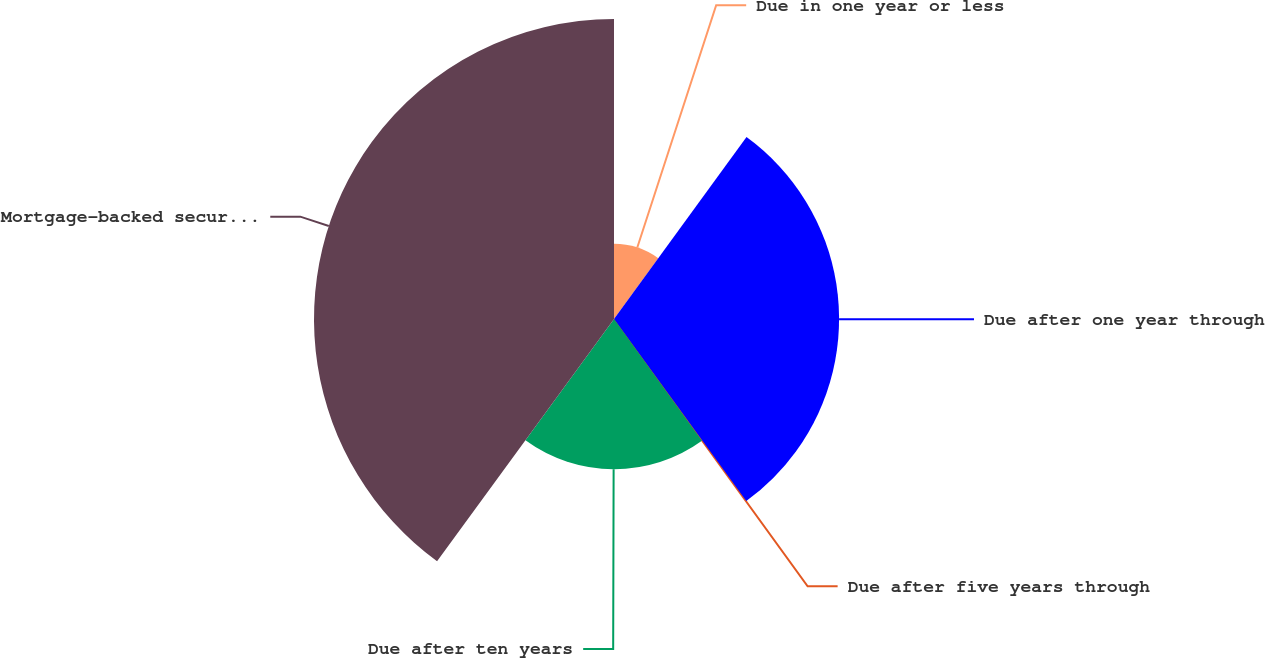<chart> <loc_0><loc_0><loc_500><loc_500><pie_chart><fcel>Due in one year or less<fcel>Due after one year through<fcel>Due after five years through<fcel>Due after ten years<fcel>Mortgage-backed securities<nl><fcel>10.02%<fcel>29.98%<fcel>0.04%<fcel>20.0%<fcel>39.96%<nl></chart> 